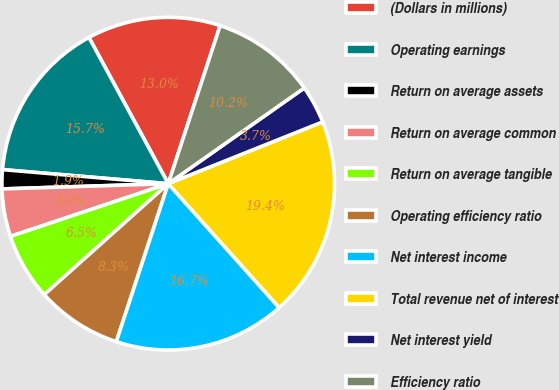Convert chart to OTSL. <chart><loc_0><loc_0><loc_500><loc_500><pie_chart><fcel>(Dollars in millions)<fcel>Operating earnings<fcel>Return on average assets<fcel>Return on average common<fcel>Return on average tangible<fcel>Operating efficiency ratio<fcel>Net interest income<fcel>Total revenue net of interest<fcel>Net interest yield<fcel>Efficiency ratio<nl><fcel>12.96%<fcel>15.74%<fcel>1.85%<fcel>4.63%<fcel>6.48%<fcel>8.33%<fcel>16.67%<fcel>19.44%<fcel>3.7%<fcel>10.19%<nl></chart> 